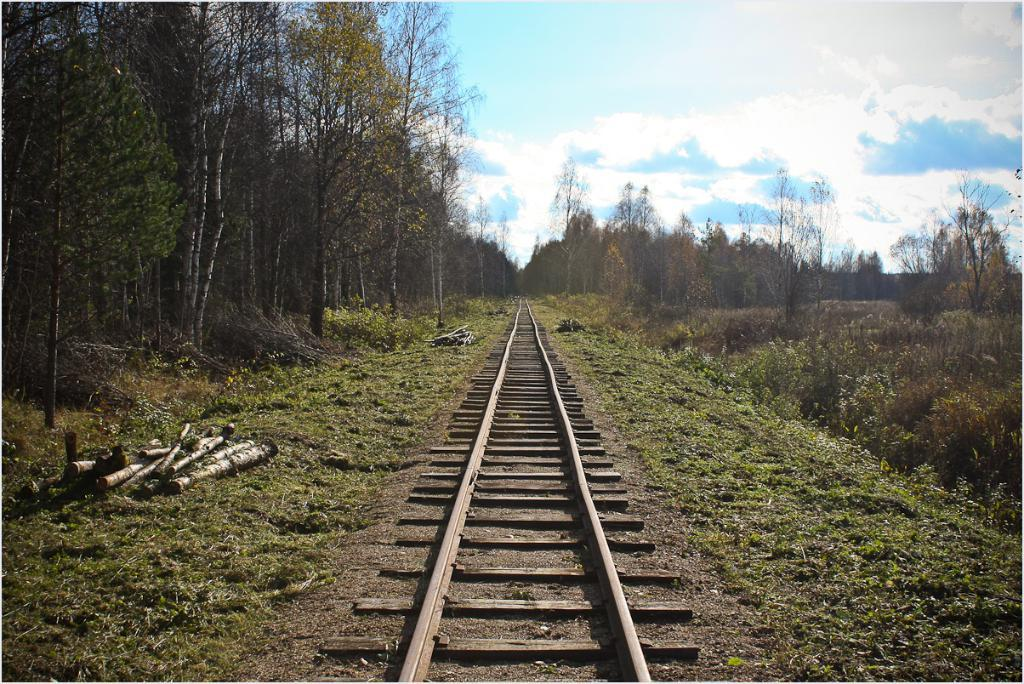What is the main feature in the center of the image? There is a railway track in the center of the image. What can be seen on the left side of the image? There are logs on the left side of the image. What is visible in the background of the image? There are trees and the sky in the background of the image. How many grapes are hanging from the trees in the image? There are no grapes visible in the image; only trees are present in the background. In which direction is the railway track heading in the image? The direction of the railway track cannot be determined from the image alone, as it only shows a portion of the track. 